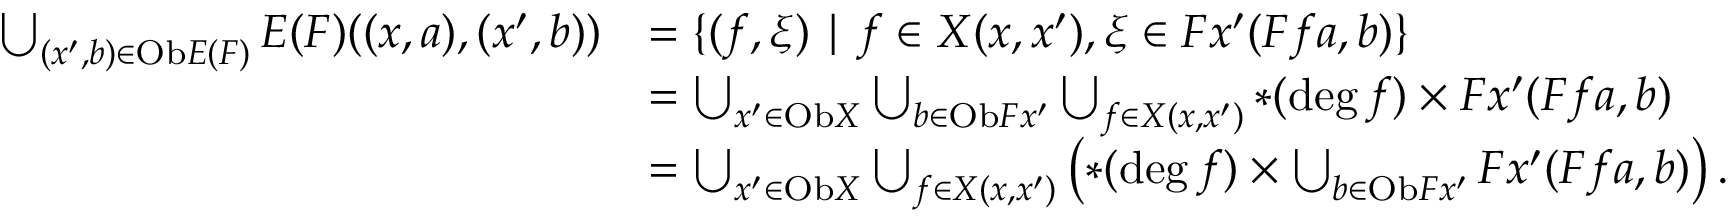Convert formula to latex. <formula><loc_0><loc_0><loc_500><loc_500>\begin{array} { r l } { \bigcup _ { ( x ^ { \prime } , b ) \in O b E ( F ) } E ( F ) ( ( x , a ) , ( x ^ { \prime } , b ) ) } & { = \{ ( f , \xi ) | f \in X ( x , x ^ { \prime } ) , \xi \in F x ^ { \prime } ( F f a , b ) \} } \\ & { = \bigcup _ { x ^ { \prime } \in O b X } \bigcup _ { b \in O b F x ^ { \prime } } \bigcup _ { f \in X ( x , x ^ { \prime } ) } \ast ( \deg f ) \times F x ^ { \prime } ( F f a , b ) } \\ & { = \bigcup _ { x ^ { \prime } \in O b X } \bigcup _ { f \in X ( x , x ^ { \prime } ) } \left ( \ast ( \deg f ) \times \bigcup _ { b \in O b F x ^ { \prime } } F x ^ { \prime } ( F f a , b ) \right ) . } \end{array}</formula> 